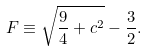<formula> <loc_0><loc_0><loc_500><loc_500>F \equiv \sqrt { \frac { 9 } { 4 } + c ^ { 2 } } - \frac { 3 } { 2 } .</formula> 